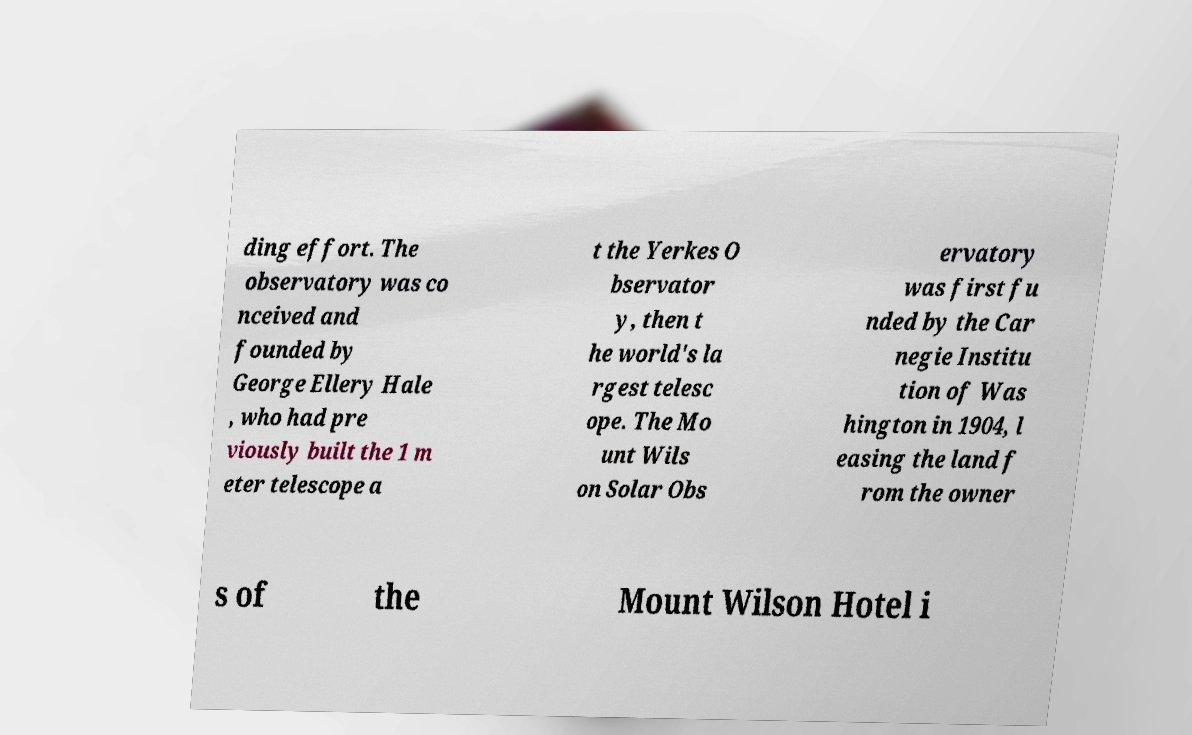Please identify and transcribe the text found in this image. ding effort. The observatory was co nceived and founded by George Ellery Hale , who had pre viously built the 1 m eter telescope a t the Yerkes O bservator y, then t he world's la rgest telesc ope. The Mo unt Wils on Solar Obs ervatory was first fu nded by the Car negie Institu tion of Was hington in 1904, l easing the land f rom the owner s of the Mount Wilson Hotel i 